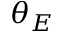Convert formula to latex. <formula><loc_0><loc_0><loc_500><loc_500>\theta _ { E }</formula> 